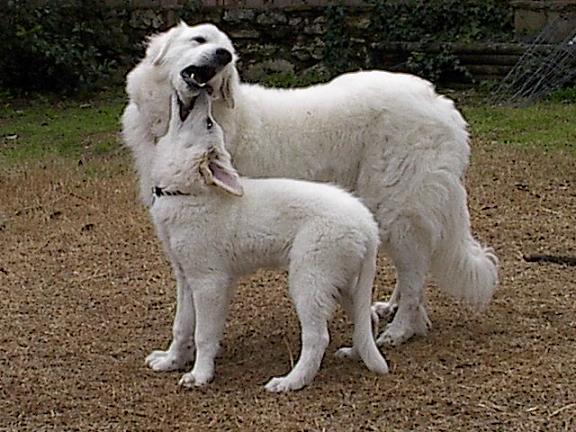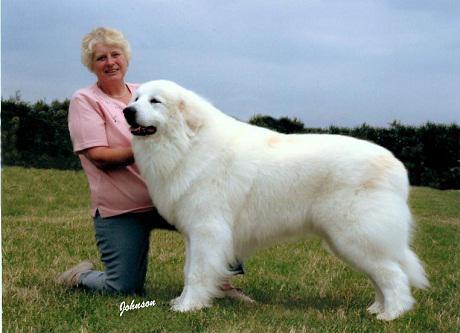The first image is the image on the left, the second image is the image on the right. Analyze the images presented: Is the assertion "There are at least two white dogs in the right image." valid? Answer yes or no. No. The first image is the image on the left, the second image is the image on the right. Examine the images to the left and right. Is the description "A large white dog at an outdoor setting is standing in a pose with a woman wearing jeans, who is leaning back slightly away from the dog." accurate? Answer yes or no. Yes. 